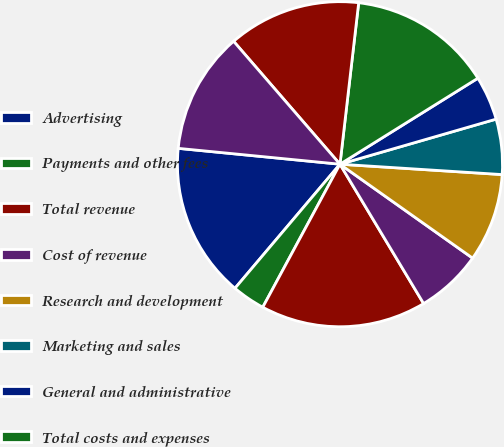Convert chart to OTSL. <chart><loc_0><loc_0><loc_500><loc_500><pie_chart><fcel>Advertising<fcel>Payments and other fees<fcel>Total revenue<fcel>Cost of revenue<fcel>Research and development<fcel>Marketing and sales<fcel>General and administrative<fcel>Total costs and expenses<fcel>Income from operations<fcel>Income before provision for<nl><fcel>15.38%<fcel>3.3%<fcel>16.48%<fcel>6.59%<fcel>8.79%<fcel>5.49%<fcel>4.4%<fcel>14.29%<fcel>13.19%<fcel>12.09%<nl></chart> 